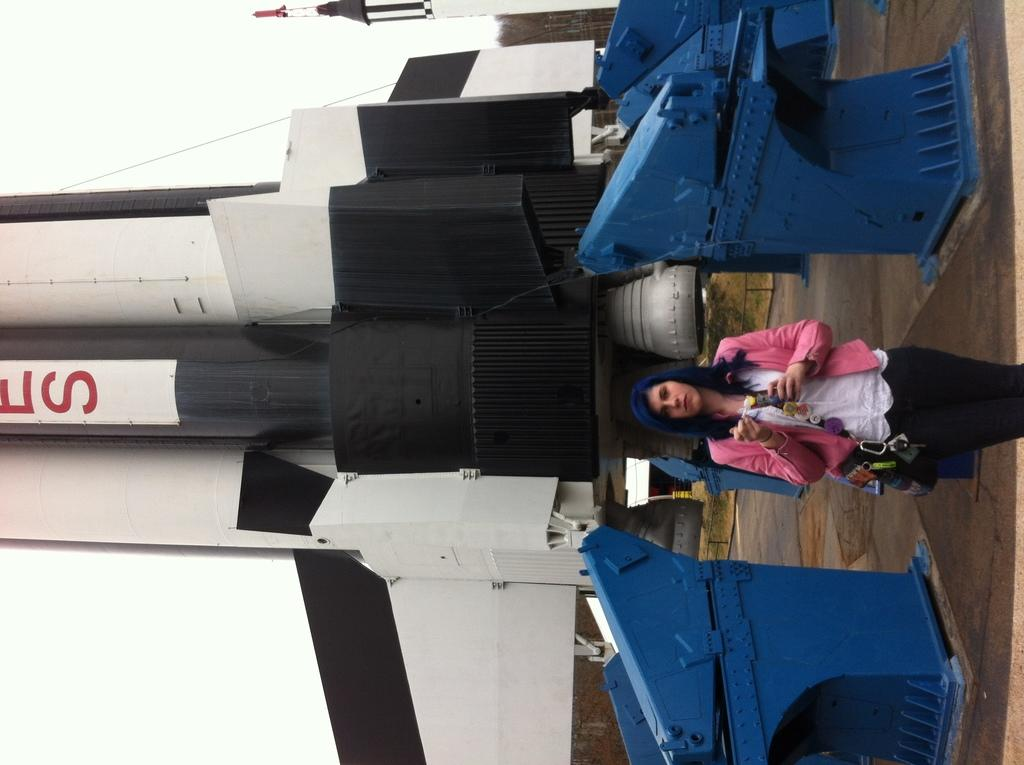Who is present on the right side of the image? There is a lady standing on the right side of the image. What is located behind the lady? There is a rocket behind the lady. What color are the objects on the ground? There are blue color things on the ground. What is the tendency of the machine in the image? There is no machine present in the image, so it is not possible to determine its tendency. 